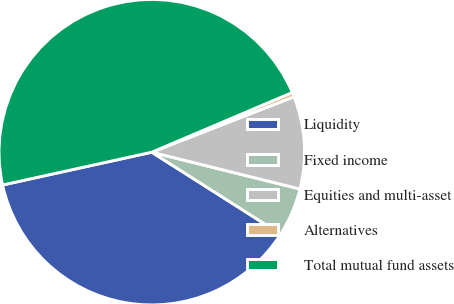<chart> <loc_0><loc_0><loc_500><loc_500><pie_chart><fcel>Liquidity<fcel>Fixed income<fcel>Equities and multi-asset<fcel>Alternatives<fcel>Total mutual fund assets<nl><fcel>37.55%<fcel>5.13%<fcel>9.79%<fcel>0.48%<fcel>47.05%<nl></chart> 